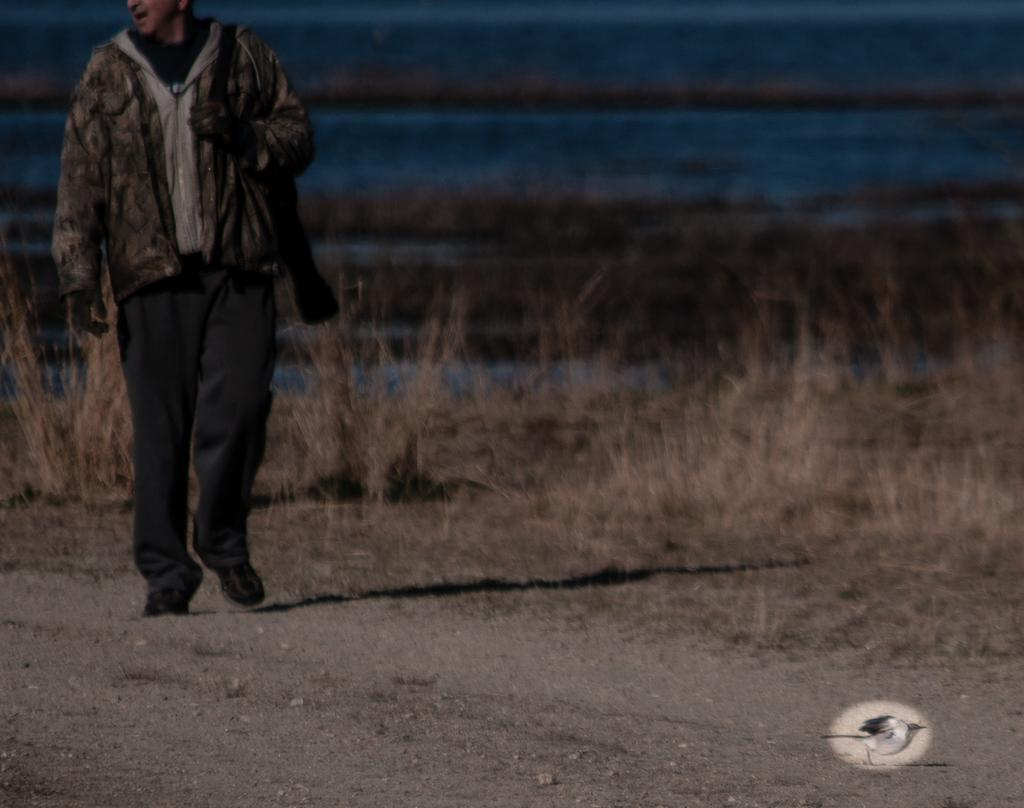What is happening on the left side of the image? There is a person walking on the left side of the image. What type of vegetation can be seen in the background of the image? There is grass visible in the background of the image. How many apples are being held by the person in the image? There are no apples visible in the image; the person is simply walking. What type of expression does the person have on their face in the image? The provided facts do not mention the person's facial expression, so we cannot determine if they are smiling or not. 